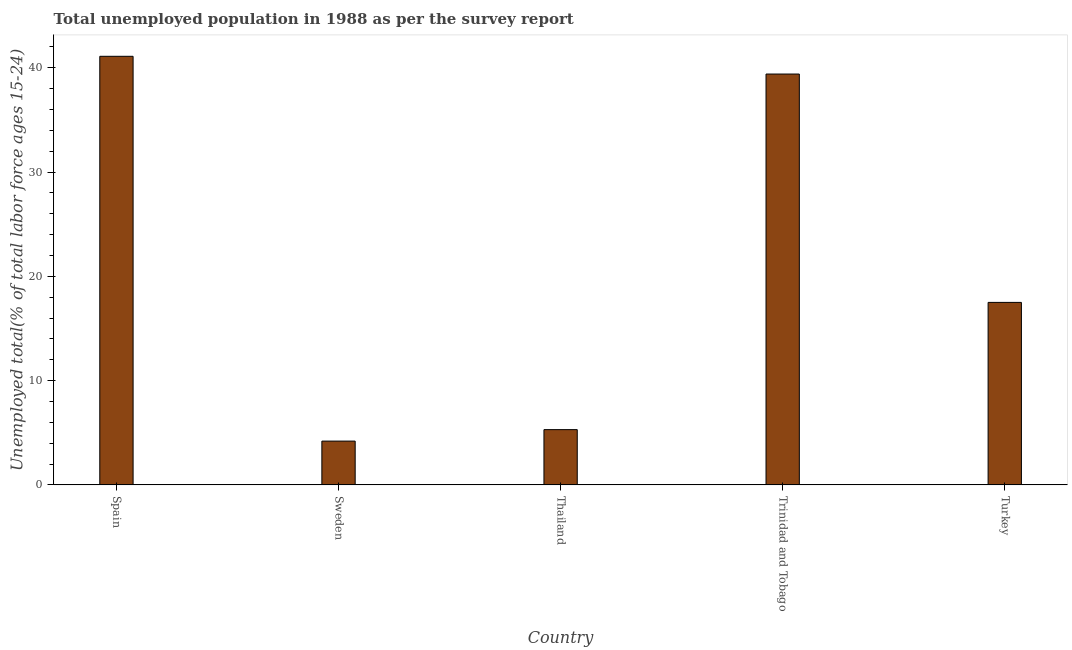What is the title of the graph?
Your answer should be compact. Total unemployed population in 1988 as per the survey report. What is the label or title of the Y-axis?
Provide a short and direct response. Unemployed total(% of total labor force ages 15-24). What is the unemployed youth in Thailand?
Give a very brief answer. 5.3. Across all countries, what is the maximum unemployed youth?
Offer a terse response. 41.1. Across all countries, what is the minimum unemployed youth?
Provide a succinct answer. 4.2. What is the sum of the unemployed youth?
Offer a very short reply. 107.5. What is the difference between the unemployed youth in Thailand and Turkey?
Make the answer very short. -12.2. What is the median unemployed youth?
Your response must be concise. 17.5. What is the ratio of the unemployed youth in Thailand to that in Turkey?
Provide a succinct answer. 0.3. Is the difference between the unemployed youth in Sweden and Thailand greater than the difference between any two countries?
Your response must be concise. No. What is the difference between the highest and the lowest unemployed youth?
Give a very brief answer. 36.9. In how many countries, is the unemployed youth greater than the average unemployed youth taken over all countries?
Give a very brief answer. 2. What is the Unemployed total(% of total labor force ages 15-24) of Spain?
Your answer should be compact. 41.1. What is the Unemployed total(% of total labor force ages 15-24) in Sweden?
Give a very brief answer. 4.2. What is the Unemployed total(% of total labor force ages 15-24) in Thailand?
Offer a terse response. 5.3. What is the Unemployed total(% of total labor force ages 15-24) of Trinidad and Tobago?
Your response must be concise. 39.4. What is the Unemployed total(% of total labor force ages 15-24) in Turkey?
Keep it short and to the point. 17.5. What is the difference between the Unemployed total(% of total labor force ages 15-24) in Spain and Sweden?
Provide a short and direct response. 36.9. What is the difference between the Unemployed total(% of total labor force ages 15-24) in Spain and Thailand?
Make the answer very short. 35.8. What is the difference between the Unemployed total(% of total labor force ages 15-24) in Spain and Trinidad and Tobago?
Offer a terse response. 1.7. What is the difference between the Unemployed total(% of total labor force ages 15-24) in Spain and Turkey?
Ensure brevity in your answer.  23.6. What is the difference between the Unemployed total(% of total labor force ages 15-24) in Sweden and Trinidad and Tobago?
Keep it short and to the point. -35.2. What is the difference between the Unemployed total(% of total labor force ages 15-24) in Thailand and Trinidad and Tobago?
Your response must be concise. -34.1. What is the difference between the Unemployed total(% of total labor force ages 15-24) in Thailand and Turkey?
Keep it short and to the point. -12.2. What is the difference between the Unemployed total(% of total labor force ages 15-24) in Trinidad and Tobago and Turkey?
Your answer should be compact. 21.9. What is the ratio of the Unemployed total(% of total labor force ages 15-24) in Spain to that in Sweden?
Offer a very short reply. 9.79. What is the ratio of the Unemployed total(% of total labor force ages 15-24) in Spain to that in Thailand?
Your answer should be compact. 7.75. What is the ratio of the Unemployed total(% of total labor force ages 15-24) in Spain to that in Trinidad and Tobago?
Your response must be concise. 1.04. What is the ratio of the Unemployed total(% of total labor force ages 15-24) in Spain to that in Turkey?
Offer a terse response. 2.35. What is the ratio of the Unemployed total(% of total labor force ages 15-24) in Sweden to that in Thailand?
Your response must be concise. 0.79. What is the ratio of the Unemployed total(% of total labor force ages 15-24) in Sweden to that in Trinidad and Tobago?
Your response must be concise. 0.11. What is the ratio of the Unemployed total(% of total labor force ages 15-24) in Sweden to that in Turkey?
Ensure brevity in your answer.  0.24. What is the ratio of the Unemployed total(% of total labor force ages 15-24) in Thailand to that in Trinidad and Tobago?
Keep it short and to the point. 0.14. What is the ratio of the Unemployed total(% of total labor force ages 15-24) in Thailand to that in Turkey?
Offer a very short reply. 0.3. What is the ratio of the Unemployed total(% of total labor force ages 15-24) in Trinidad and Tobago to that in Turkey?
Your answer should be very brief. 2.25. 